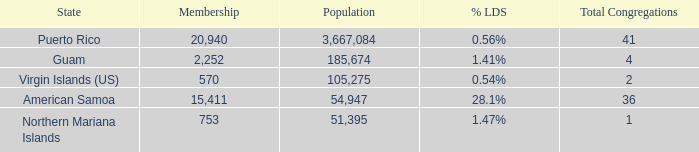What is the total number of Total Congregations, when % LDS is 0.54%, and when Population is greater than 105,275? 0.0. 